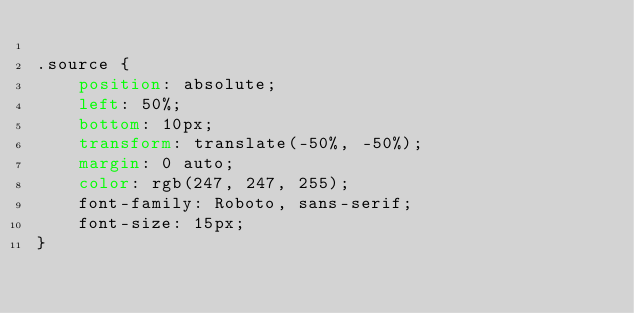Convert code to text. <code><loc_0><loc_0><loc_500><loc_500><_CSS_>
.source {
    position: absolute;
    left: 50%;
    bottom: 10px;
    transform: translate(-50%, -50%);
    margin: 0 auto;
    color: rgb(247, 247, 255);
    font-family: Roboto, sans-serif;
    font-size: 15px;
}</code> 